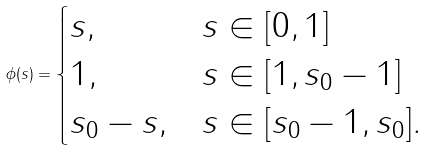Convert formula to latex. <formula><loc_0><loc_0><loc_500><loc_500>\phi ( s ) = \begin{cases} s , & s \in [ 0 , 1 ] \\ 1 , & s \in [ 1 , s _ { 0 } - 1 ] \\ s _ { 0 } - s , & s \in [ s _ { 0 } - 1 , s _ { 0 } ] . \end{cases}</formula> 